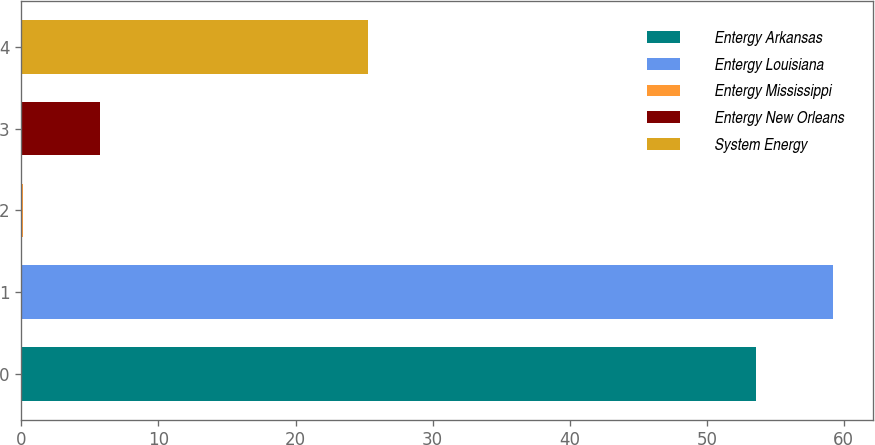<chart> <loc_0><loc_0><loc_500><loc_500><bar_chart><fcel>Entergy Arkansas<fcel>Entergy Louisiana<fcel>Entergy Mississippi<fcel>Entergy New Orleans<fcel>System Energy<nl><fcel>53.6<fcel>59.2<fcel>0.1<fcel>5.7<fcel>25.3<nl></chart> 